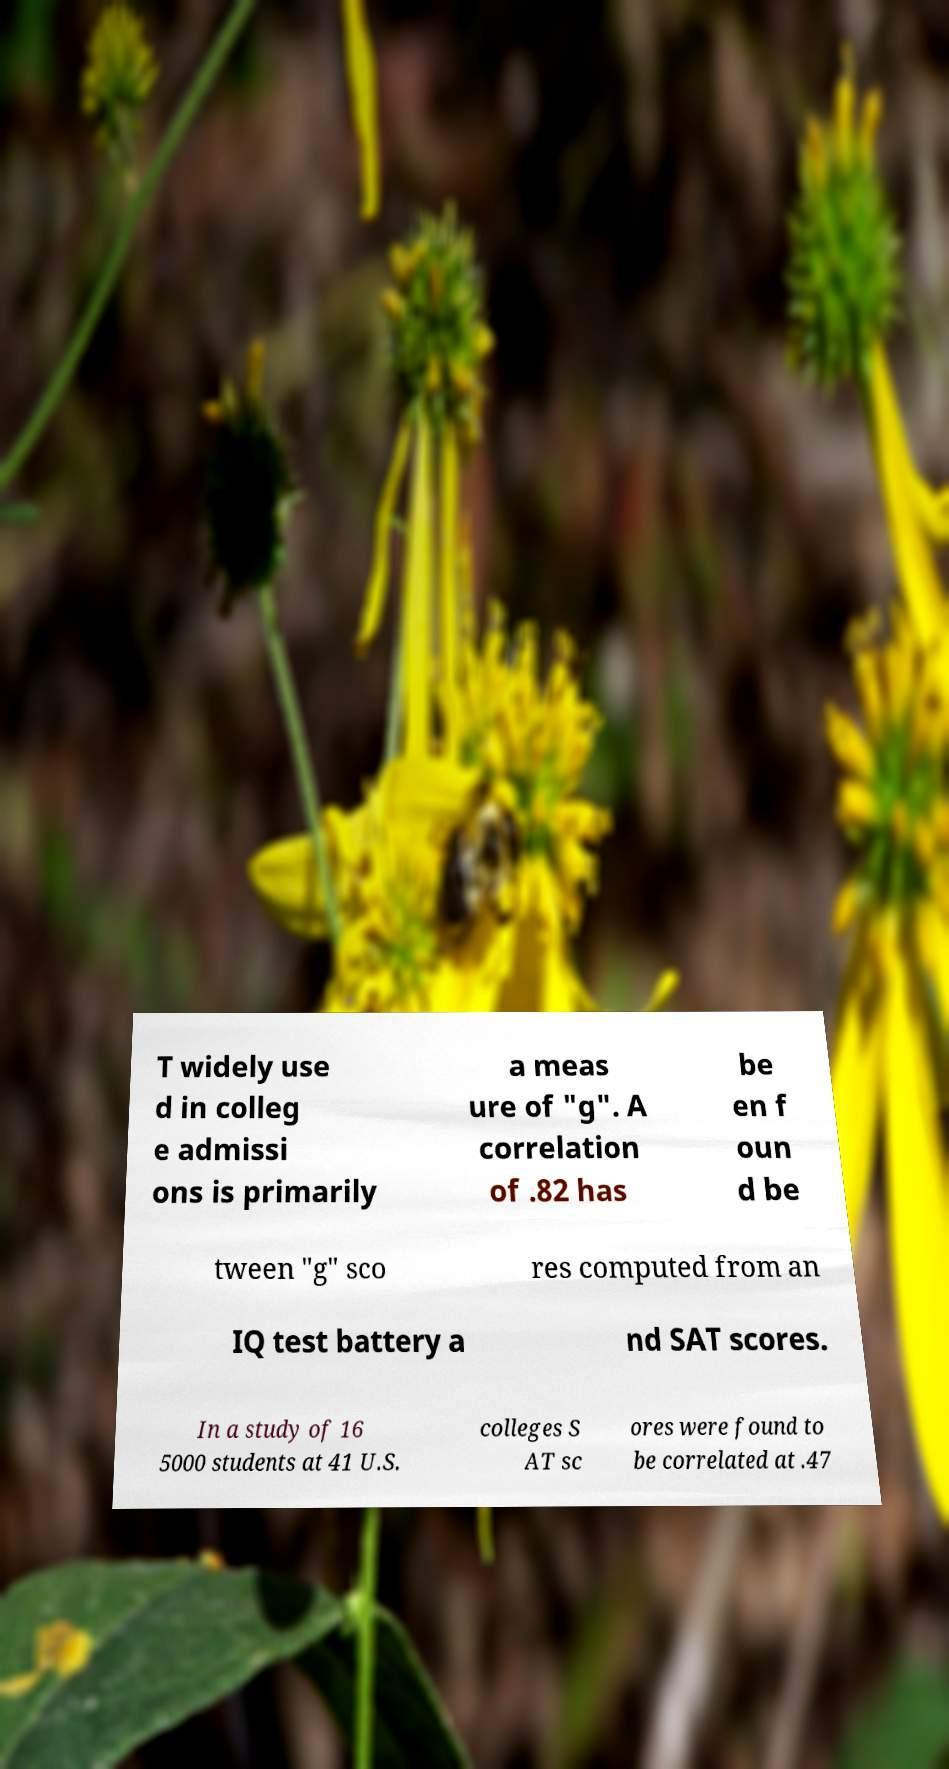Could you extract and type out the text from this image? T widely use d in colleg e admissi ons is primarily a meas ure of "g". A correlation of .82 has be en f oun d be tween "g" sco res computed from an IQ test battery a nd SAT scores. In a study of 16 5000 students at 41 U.S. colleges S AT sc ores were found to be correlated at .47 